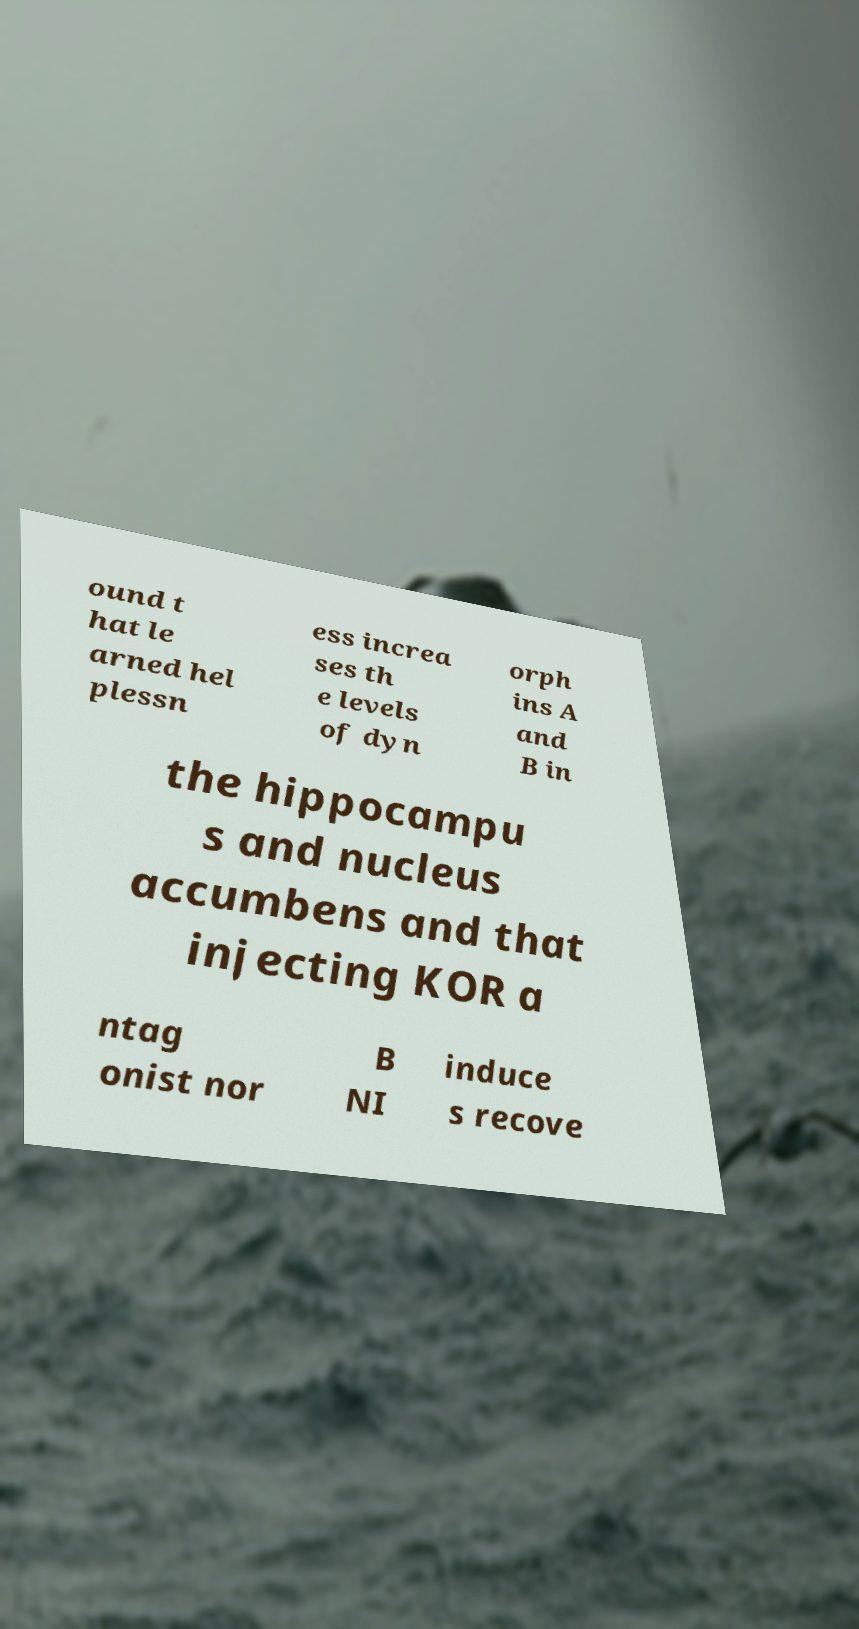Can you read and provide the text displayed in the image?This photo seems to have some interesting text. Can you extract and type it out for me? ound t hat le arned hel plessn ess increa ses th e levels of dyn orph ins A and B in the hippocampu s and nucleus accumbens and that injecting KOR a ntag onist nor B NI induce s recove 